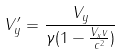<formula> <loc_0><loc_0><loc_500><loc_500>V _ { y } ^ { \prime } = \frac { V _ { y } } { \gamma ( 1 - \frac { V _ { x } v } { c ^ { 2 } } ) }</formula> 